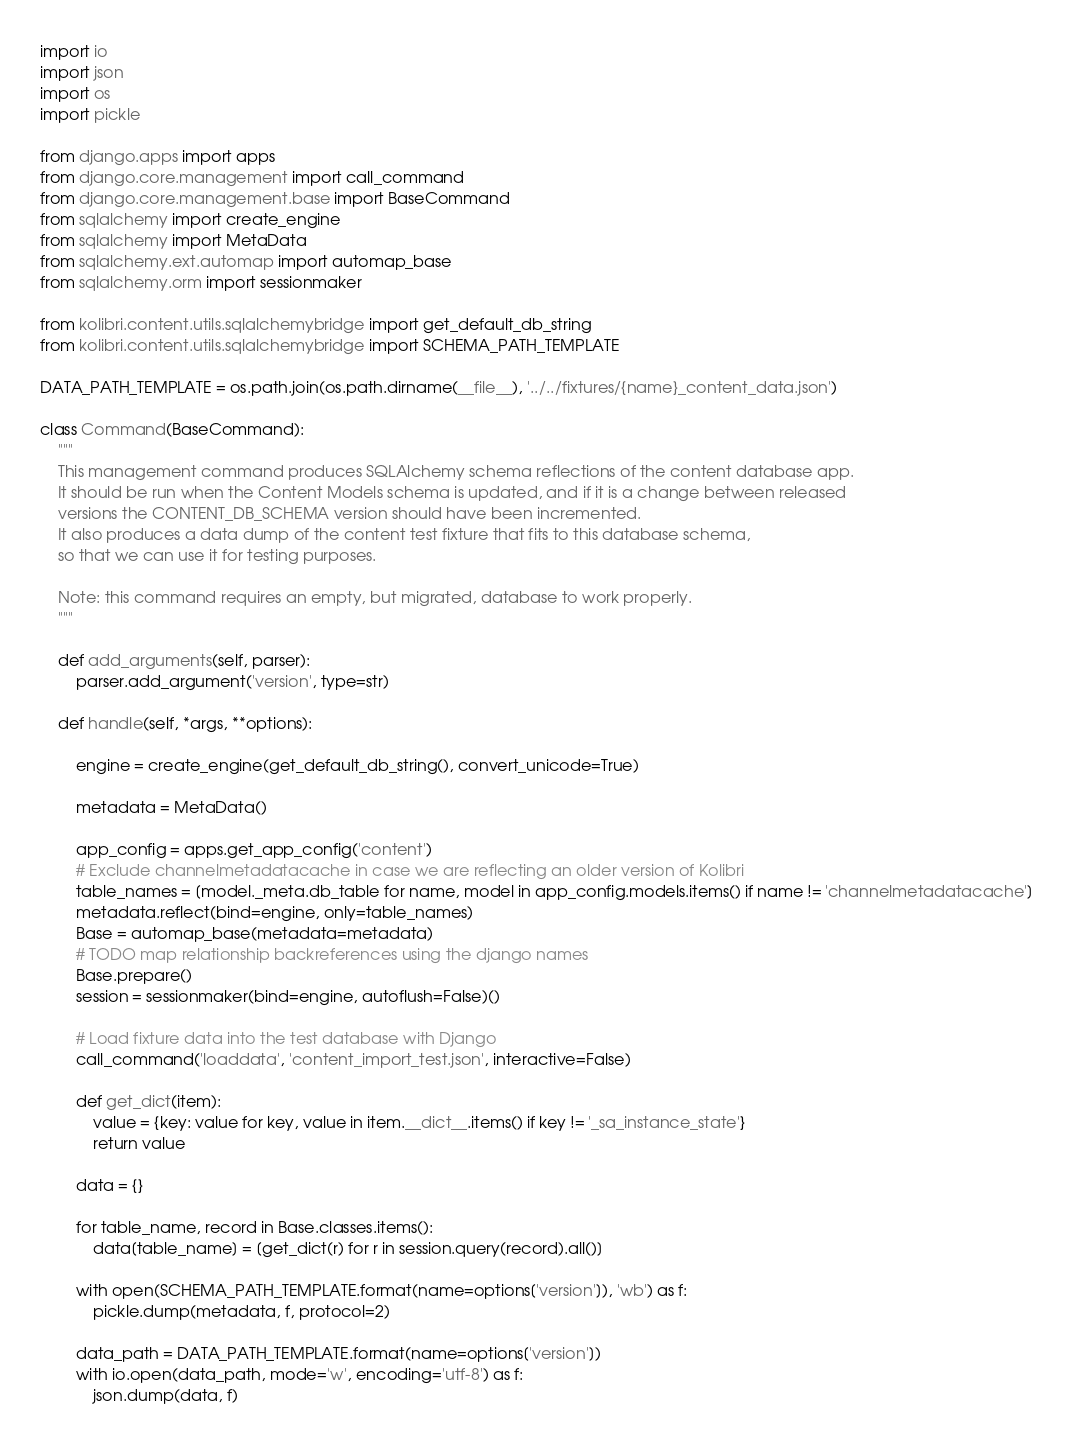<code> <loc_0><loc_0><loc_500><loc_500><_Python_>import io
import json
import os
import pickle

from django.apps import apps
from django.core.management import call_command
from django.core.management.base import BaseCommand
from sqlalchemy import create_engine
from sqlalchemy import MetaData
from sqlalchemy.ext.automap import automap_base
from sqlalchemy.orm import sessionmaker

from kolibri.content.utils.sqlalchemybridge import get_default_db_string
from kolibri.content.utils.sqlalchemybridge import SCHEMA_PATH_TEMPLATE

DATA_PATH_TEMPLATE = os.path.join(os.path.dirname(__file__), '../../fixtures/{name}_content_data.json')

class Command(BaseCommand):
    """
    This management command produces SQLAlchemy schema reflections of the content database app.
    It should be run when the Content Models schema is updated, and if it is a change between released
    versions the CONTENT_DB_SCHEMA version should have been incremented.
    It also produces a data dump of the content test fixture that fits to this database schema,
    so that we can use it for testing purposes.

    Note: this command requires an empty, but migrated, database to work properly.
    """

    def add_arguments(self, parser):
        parser.add_argument('version', type=str)

    def handle(self, *args, **options):

        engine = create_engine(get_default_db_string(), convert_unicode=True)

        metadata = MetaData()

        app_config = apps.get_app_config('content')
        # Exclude channelmetadatacache in case we are reflecting an older version of Kolibri
        table_names = [model._meta.db_table for name, model in app_config.models.items() if name != 'channelmetadatacache']
        metadata.reflect(bind=engine, only=table_names)
        Base = automap_base(metadata=metadata)
        # TODO map relationship backreferences using the django names
        Base.prepare()
        session = sessionmaker(bind=engine, autoflush=False)()

        # Load fixture data into the test database with Django
        call_command('loaddata', 'content_import_test.json', interactive=False)

        def get_dict(item):
            value = {key: value for key, value in item.__dict__.items() if key != '_sa_instance_state'}
            return value

        data = {}

        for table_name, record in Base.classes.items():
            data[table_name] = [get_dict(r) for r in session.query(record).all()]

        with open(SCHEMA_PATH_TEMPLATE.format(name=options['version']), 'wb') as f:
            pickle.dump(metadata, f, protocol=2)

        data_path = DATA_PATH_TEMPLATE.format(name=options['version'])
        with io.open(data_path, mode='w', encoding='utf-8') as f:
            json.dump(data, f)
</code> 